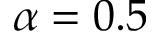<formula> <loc_0><loc_0><loc_500><loc_500>\alpha = 0 . 5</formula> 